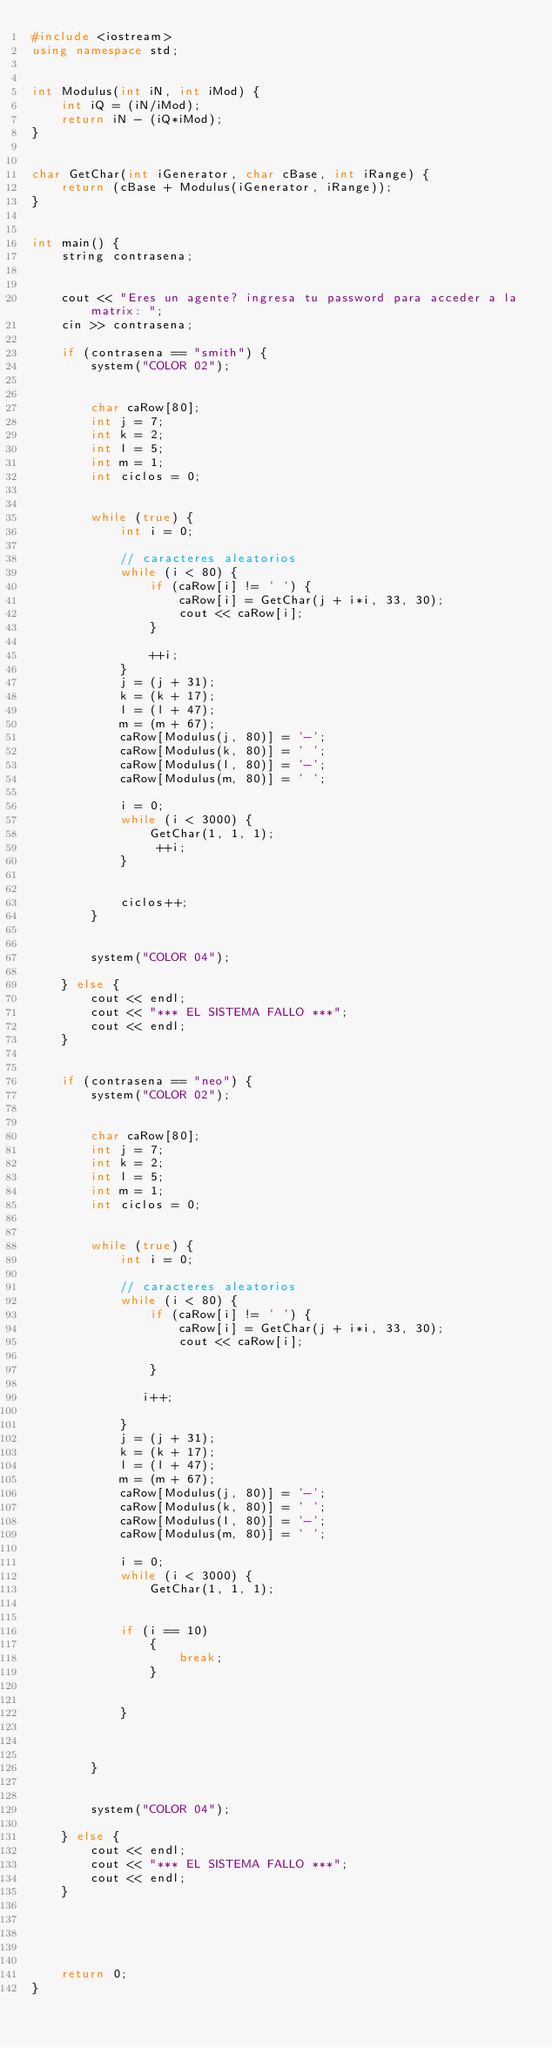Convert code to text. <code><loc_0><loc_0><loc_500><loc_500><_C++_>#include <iostream>
using namespace std;
 

int Modulus(int iN, int iMod) {
    int iQ = (iN/iMod);
    return iN - (iQ*iMod);
}
 

char GetChar(int iGenerator, char cBase, int iRange) {
    return (cBase + Modulus(iGenerator, iRange));
}
 

int main() {
    string contrasena;

    
    cout << "Eres un agente? ingresa tu password para acceder a la matrix: ";
    cin >> contrasena;
    
    if (contrasena == "smith") {
        system("COLOR 02");
 

        char caRow[80];
        int j = 7;
        int k = 2;
        int l = 5;
        int m = 1;
        int ciclos = 0;
 

        while (true) {
            int i = 0;
            
            // caracteres aleatorios
            while (i < 80) {
                if (caRow[i] != ' ') {
                    caRow[i] = GetChar(j + i*i, 33, 30);
                    cout << caRow[i];
                }
                
                ++i;
            }
            j = (j + 31);
            k = (k + 17);
            l = (l + 47);
            m = (m + 67);
            caRow[Modulus(j, 80)] = '-';
            caRow[Modulus(k, 80)] = ' ';
            caRow[Modulus(l, 80)] = '-';
            caRow[Modulus(m, 80)] = ' ';
            
            i = 0;
            while (i < 3000) {
                GetChar(1, 1, 1);
                 ++i;
            }
 

            ciclos++;
        }       
 

        system("COLOR 04");
        
    } else {
        cout << endl;
        cout << "*** EL SISTEMA FALLO ***";
        cout << endl;
    }
   

    if (contrasena == "neo") {
        system("COLOR 02");
 

        char caRow[80];
        int j = 7;
        int k = 2;
        int l = 5;
        int m = 1;
        int ciclos = 0;
 

        while (true) {
            int i = 0;
            
            // caracteres aleatorios
            while (i < 80) {
                if (caRow[i] != ' ') {
                    caRow[i] = GetChar(j + i*i, 33, 30);
                    cout << caRow[i];
                    
                }
                
               i++;

            }
            j = (j + 31);
            k = (k + 17);
            l = (l + 47);
            m = (m + 67);
            caRow[Modulus(j, 80)] = '-';
            caRow[Modulus(k, 80)] = ' ';
            caRow[Modulus(l, 80)] = '-';
            caRow[Modulus(m, 80)] = ' ';
            
            i = 0;
            while (i < 3000) {
                GetChar(1, 1, 1);
             
            
            if (i == 10)
                {
                    break;
                }
            

            }
         
          
            
        }   
 
        
        system("COLOR 04");
        
    } else {
        cout << endl;
        cout << "*** EL SISTEMA FALLO ***";
        cout << endl;
    }
    
    
    
     

    return 0;
}
</code> 